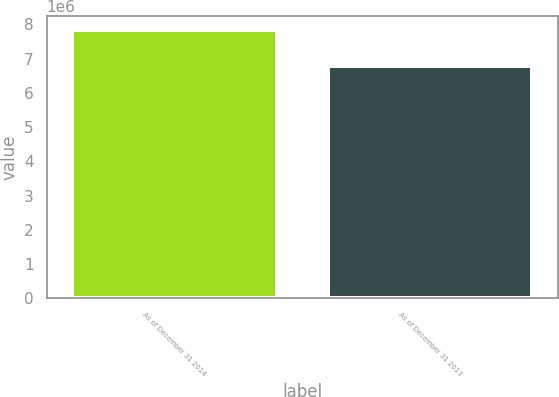<chart> <loc_0><loc_0><loc_500><loc_500><bar_chart><fcel>As of December 31 2014<fcel>As of December 31 2013<nl><fcel>7.84112e+06<fcel>6.78319e+06<nl></chart> 